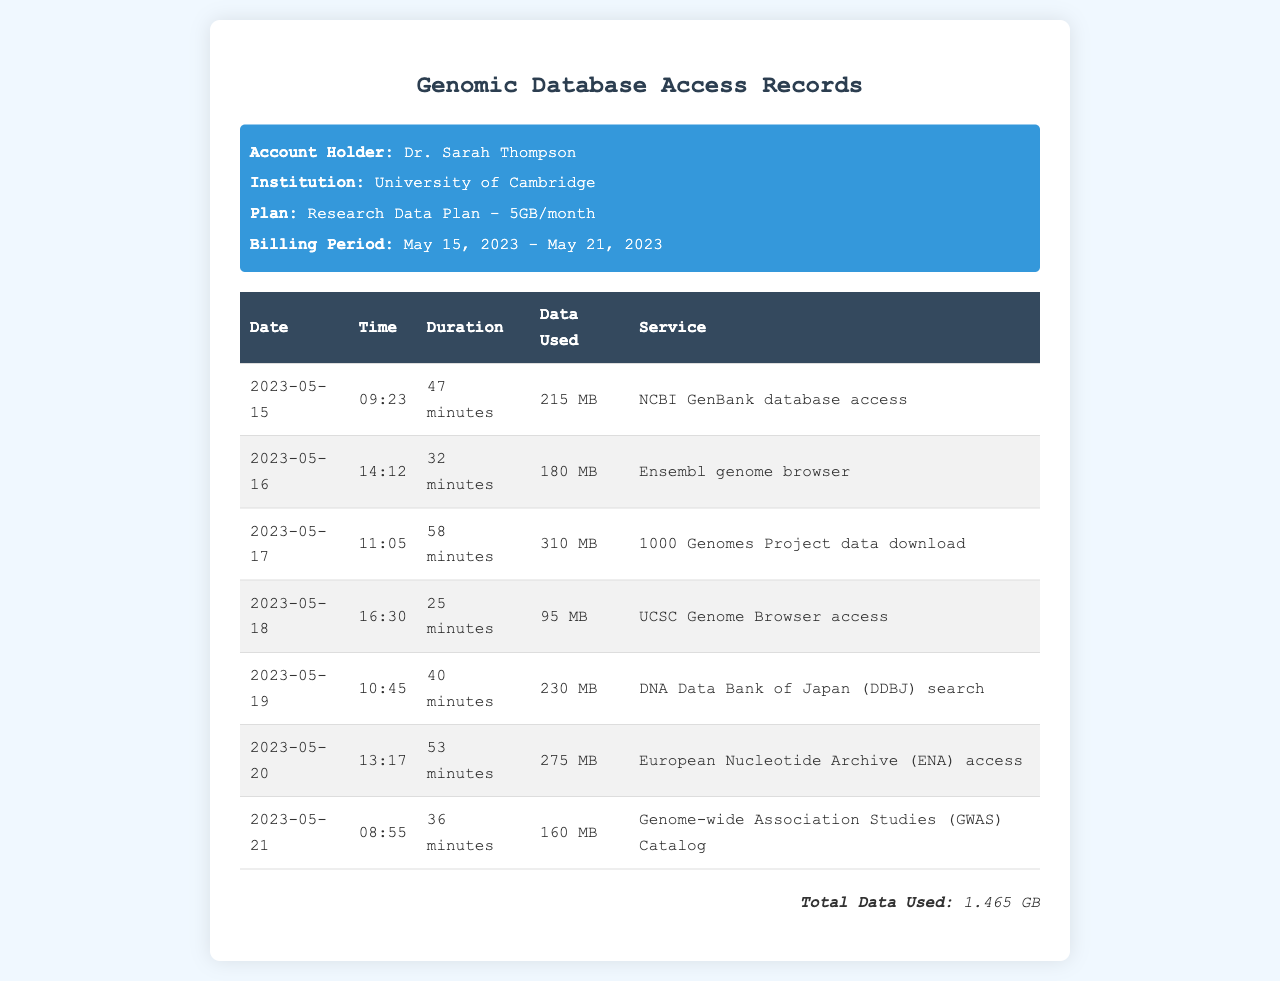What is the account holder's name? The account holder's name is mentioned in the header of the document.
Answer: Dr. Sarah Thompson What institution is associated with the account holder? The institution is listed right below the account holder's name in the document.
Answer: University of Cambridge What is the billing period for the data usage? The billing period is specified in the header section of the document.
Answer: May 15, 2023 - May 21, 2023 How much total data was used? The total data used is stated in the footer of the document.
Answer: 1.465 GB What service was accessed the most in terms of data used? The services accessed are listed in a table, and the one with the highest data usage needs to be determined.
Answer: 1000 Genomes Project data download On which date was the UCSC Genome Browser accessed? The date for each service accessed is listed in the table.
Answer: 2023-05-18 What was the duration of access for the Ensembl genome browser? The duration is included in the table next to the date and data used for that service.
Answer: 32 minutes Which date had the highest data usage? This requires comparing all data usage figures across the dates to identify the highest.
Answer: 310 MB (on 2023-05-17) What time was access to the Genome-wide Association Studies (GWAS) Catalog? The time is specified in the table next to the corresponding date and duration.
Answer: 08:55 